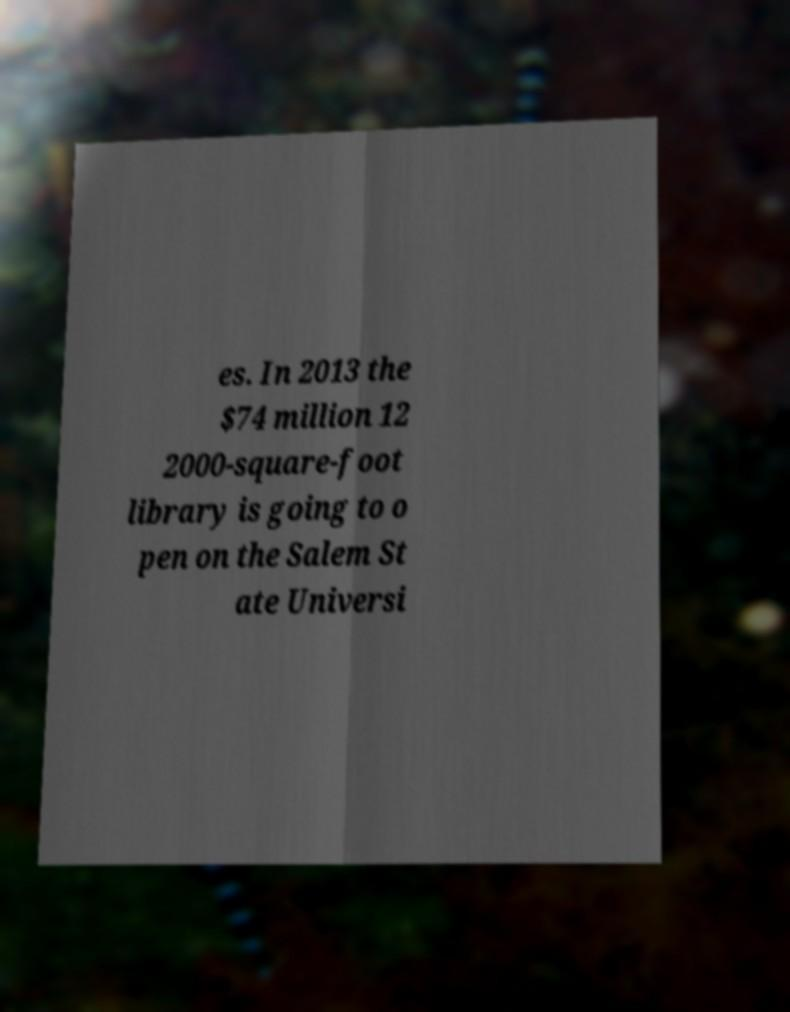Could you extract and type out the text from this image? es. In 2013 the $74 million 12 2000-square-foot library is going to o pen on the Salem St ate Universi 